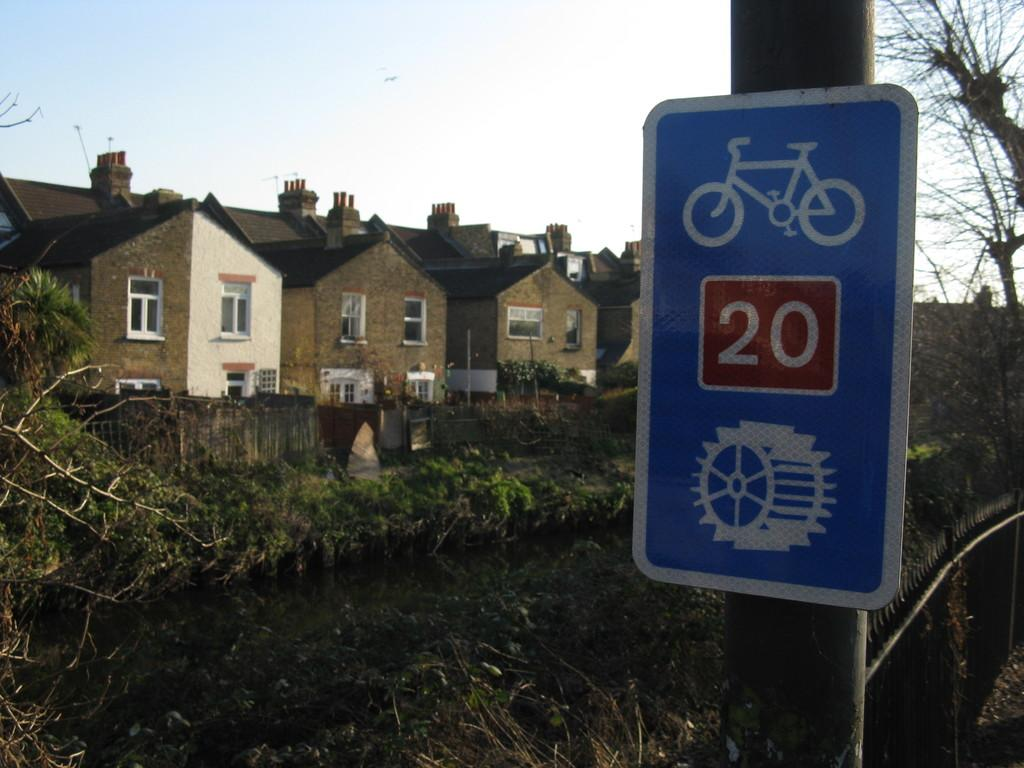<image>
Summarize the visual content of the image. A sign featuring a bicycle says the number 20 in a red box. 